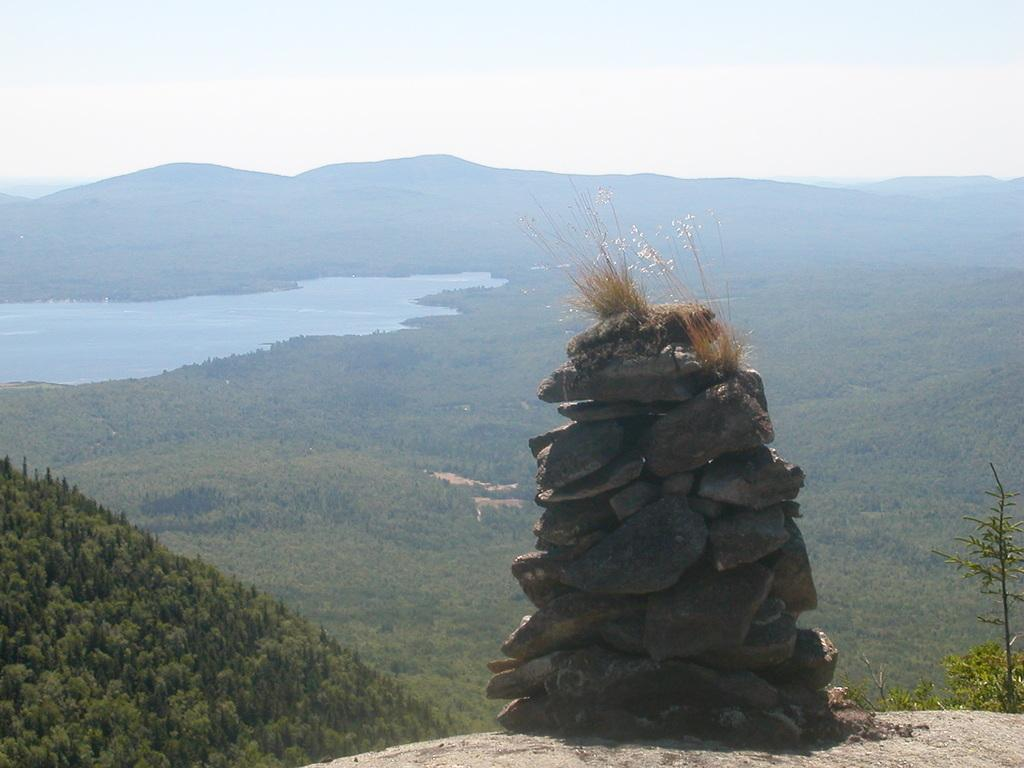What type of natural formation can be seen in the image? There are mountains in the image. What type of vegetation is present in the image? There are trees and plants in the image. What can be found in the foreground of the image? There are stones in the foreground of the image. What part of the natural environment is visible at the top of the image? The sky is visible at the top of the image. What type of body of water is visible in the image? There is water visible at the bottom of the image. Can you tell me how many necks are visible in the image? There are no necks visible in the image; it features mountains, trees, plants, stones, sky, and water. What type of tool is being used to fix the end of the mountain in the image? There is no tool or repair work being done in the image; it is a natural landscape featuring mountains, trees, plants, stones, sky, and water. 